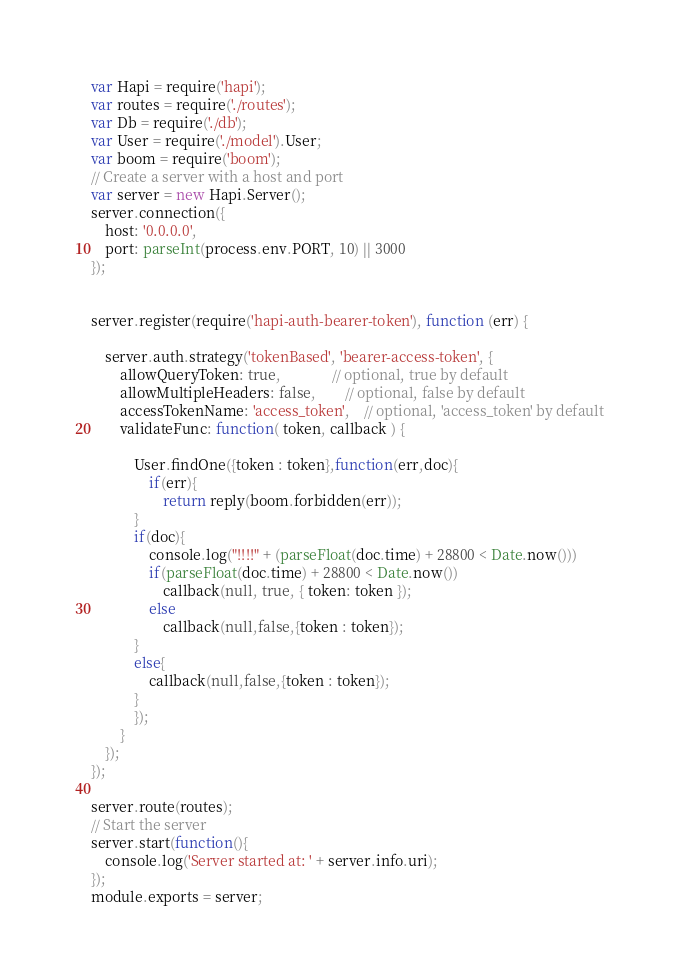Convert code to text. <code><loc_0><loc_0><loc_500><loc_500><_JavaScript_>var Hapi = require('hapi');
var routes = require('./routes');
var Db = require('./db');
var User = require('./model').User;
var boom = require('boom');
// Create a server with a host and port
var server = new Hapi.Server();
server.connection({ 
    host: '0.0.0.0', 
    port: parseInt(process.env.PORT, 10) || 3000
});


server.register(require('hapi-auth-bearer-token'), function (err) {

    server.auth.strategy('tokenBased', 'bearer-access-token', {
        allowQueryToken: true,              // optional, true by default
        allowMultipleHeaders: false,        // optional, false by default
        accessTokenName: 'access_token',    // optional, 'access_token' by default
        validateFunc: function( token, callback ) {
			
			User.findOne({token : token},function(err,doc){
				if(err){
					return reply(boom.forbidden(err));
			}
			if(doc){
				console.log("!!!!" + (parseFloat(doc.time) + 28800 < Date.now()))
				if(parseFloat(doc.time) + 28800 < Date.now())
					callback(null, true, { token: token });
				else
					callback(null,false,{token : token});
			}
			else{
				callback(null,false,{token : token});
			}
			});
        }
    });
});

server.route(routes);
// Start the server
server.start(function(){
	console.log('Server started at: ' + server.info.uri);
});
module.exports = server;</code> 